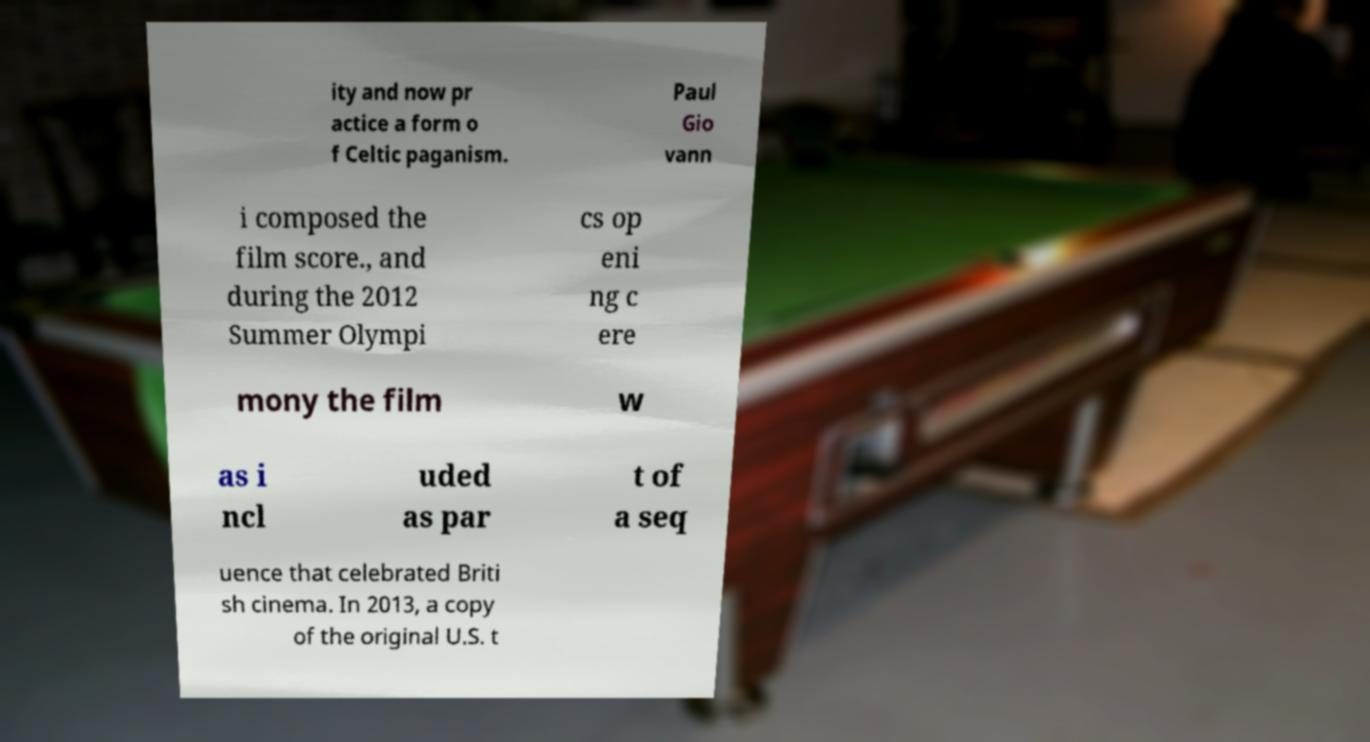Can you read and provide the text displayed in the image?This photo seems to have some interesting text. Can you extract and type it out for me? ity and now pr actice a form o f Celtic paganism. Paul Gio vann i composed the film score., and during the 2012 Summer Olympi cs op eni ng c ere mony the film w as i ncl uded as par t of a seq uence that celebrated Briti sh cinema. In 2013, a copy of the original U.S. t 